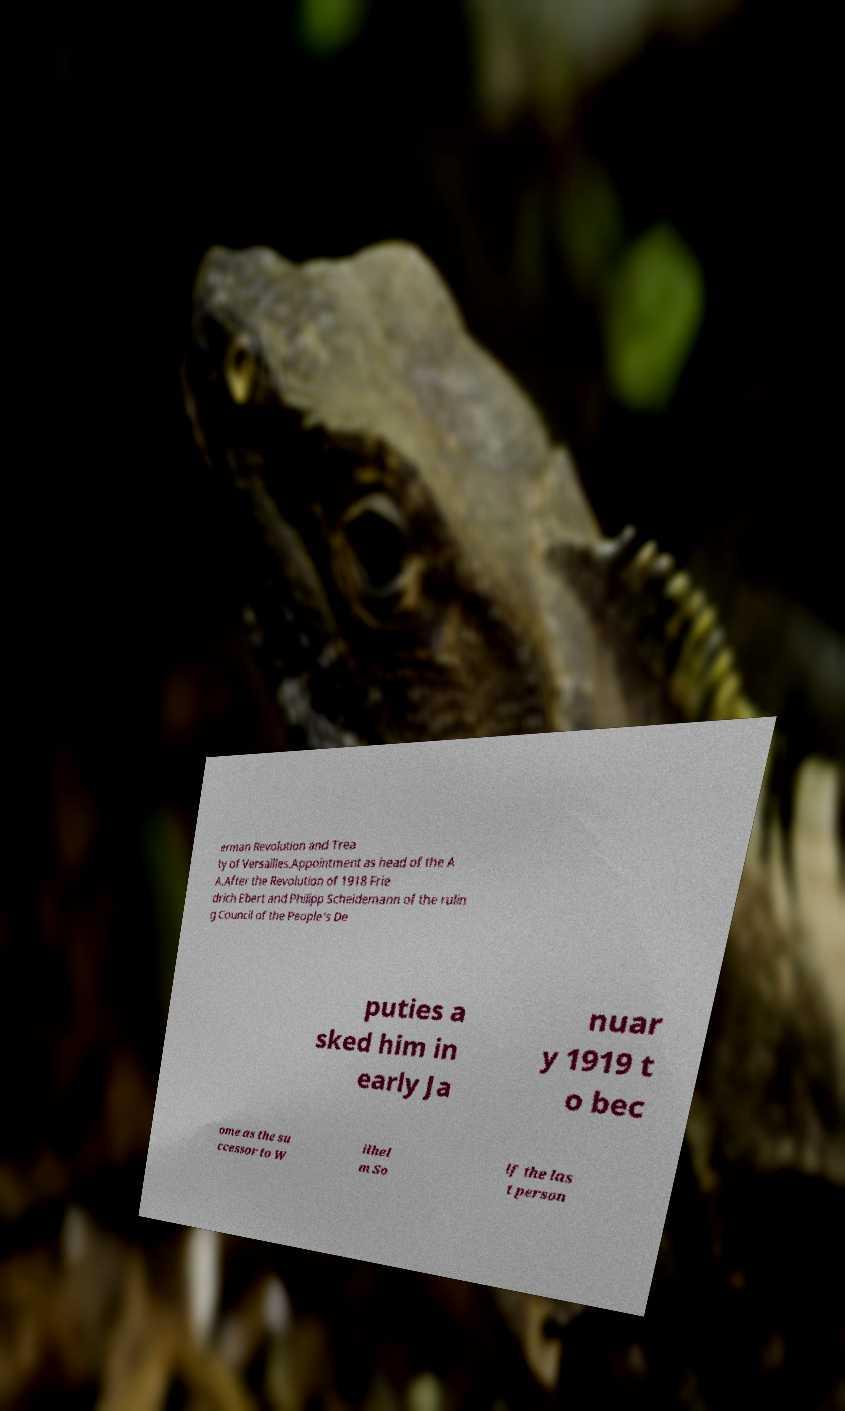For documentation purposes, I need the text within this image transcribed. Could you provide that? erman Revolution and Trea ty of Versailles.Appointment as head of the A A.After the Revolution of 1918 Frie drich Ebert and Philipp Scheidemann of the rulin g Council of the People's De puties a sked him in early Ja nuar y 1919 t o bec ome as the su ccessor to W ilhel m So lf the las t person 